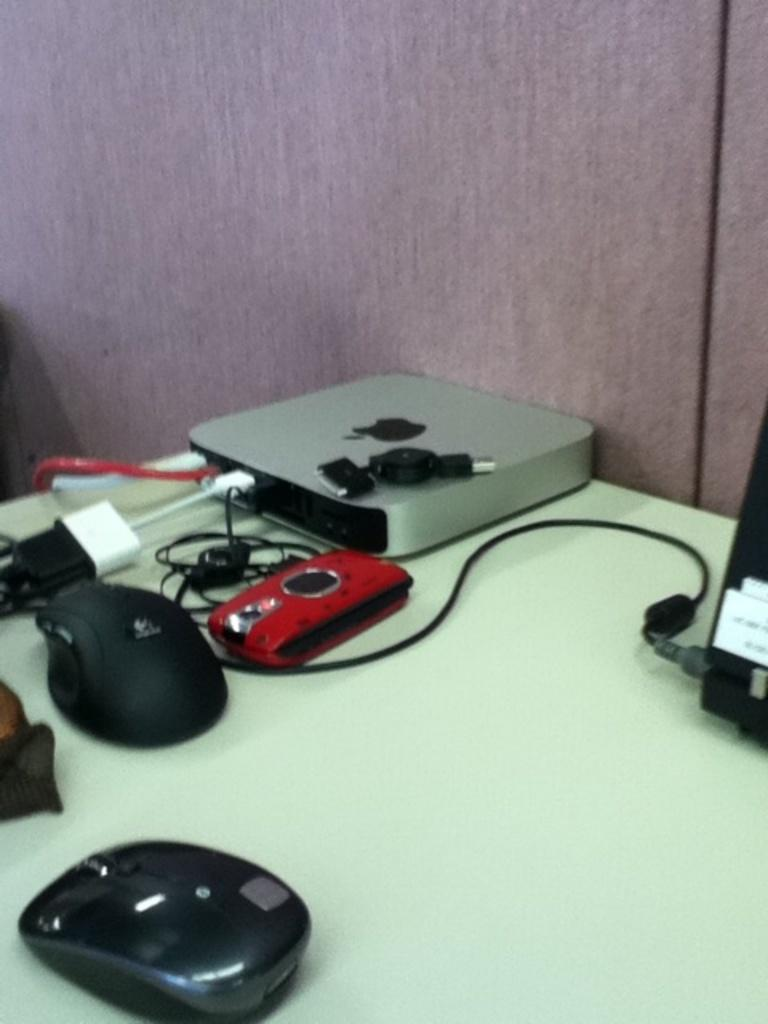What type of objects can be seen in the image? There are cables and computer mouses in the image. What is the location of these objects? The objects are on a table in the image. What can be seen in the background of the image? There is a wall in the background of the image. How many feet are visible in the image? There are no feet visible in the image. What type of coin can be seen on the table in the image? There is no coin, such as a quarter, present in the image. 